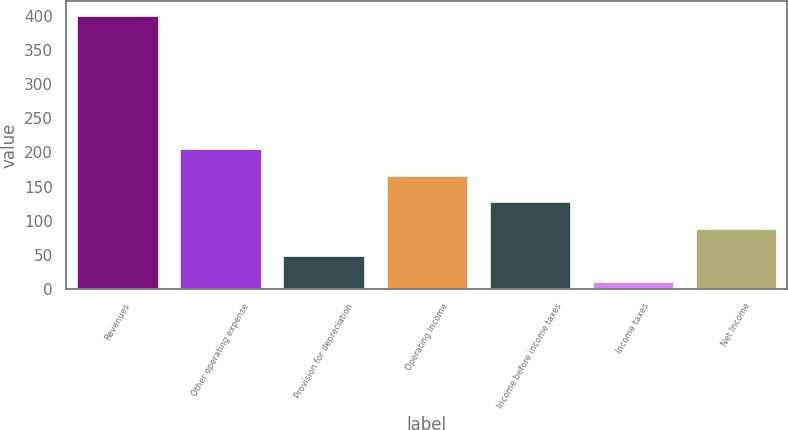Convert chart. <chart><loc_0><loc_0><loc_500><loc_500><bar_chart><fcel>Revenues<fcel>Other operating expense<fcel>Provision for depreciation<fcel>Operating Income<fcel>Income before income taxes<fcel>Income taxes<fcel>Net Income<nl><fcel>402<fcel>206.5<fcel>50.1<fcel>167.4<fcel>128.3<fcel>11<fcel>89.2<nl></chart> 